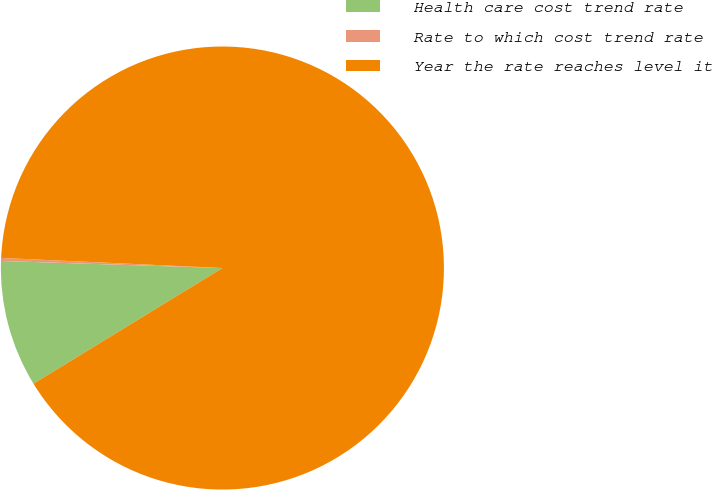Convert chart to OTSL. <chart><loc_0><loc_0><loc_500><loc_500><pie_chart><fcel>Health care cost trend rate<fcel>Rate to which cost trend rate<fcel>Year the rate reaches level it<nl><fcel>9.25%<fcel>0.22%<fcel>90.52%<nl></chart> 